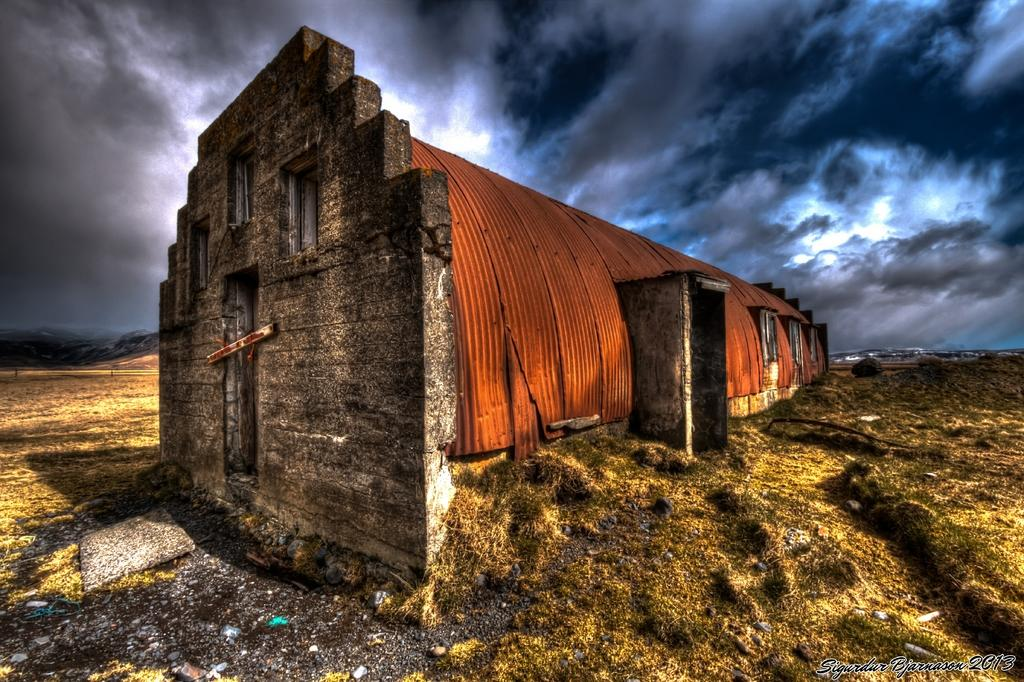What type of structure is in the image? There is a building in the image. What colors are used for the building? The building is in brown and grey colors. What feature can be seen on the building? The building has windows. Where is the building located? The building is on the ground. What can be seen in the sky in the background of the image? There are many clouds visible in the sky in the background of the image. What part of the natural environment is visible in the image? The sky is visible in the background of the image. What type of activity is taking place in the wilderness in the image? There is no wilderness or activity present in the image; it features a building with windows and a sky with clouds. What is the weight of the building in the image? The weight of the building cannot be determined from the image alone, as it would require additional information about the materials and construction of the building. 